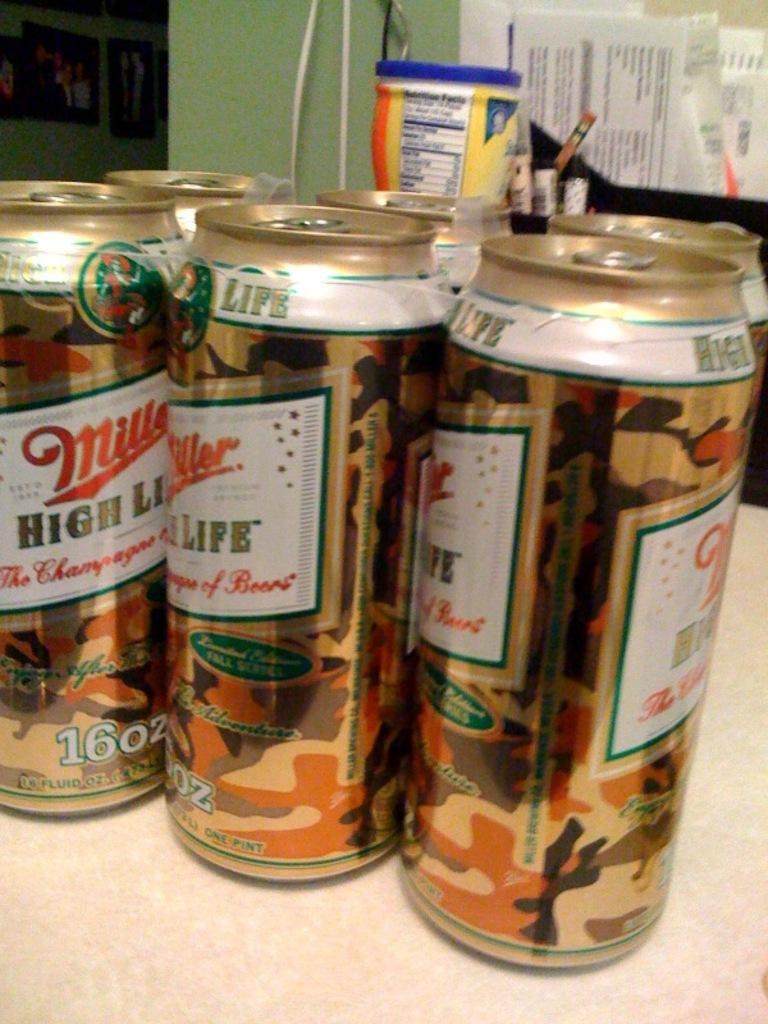<image>
Create a compact narrative representing the image presented. A couple of Miller High Life 16 oz cans. 